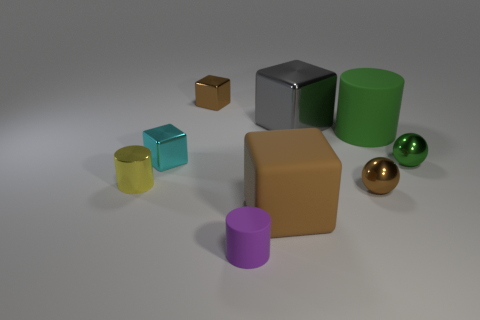What is the material of the tiny thing that is behind the small brown ball and on the right side of the rubber cube?
Your answer should be very brief. Metal. Is the number of small cylinders that are behind the big gray thing less than the number of green spheres that are behind the tiny brown shiny sphere?
Provide a short and direct response. Yes. There is a cyan thing that is the same material as the gray thing; what size is it?
Your answer should be compact. Small. Is there any other thing that is the same color as the large matte cylinder?
Keep it short and to the point. Yes. Is the purple object made of the same material as the cylinder on the right side of the purple rubber cylinder?
Give a very brief answer. Yes. What is the material of the tiny brown thing that is the same shape as the small cyan metallic thing?
Your response must be concise. Metal. Are there any other things that are made of the same material as the green cylinder?
Offer a terse response. Yes. Is the material of the small object on the left side of the tiny cyan metal block the same as the brown object that is on the left side of the tiny purple cylinder?
Your answer should be very brief. Yes. There is a cylinder that is behind the small cube that is to the left of the small cube that is behind the tiny cyan object; what color is it?
Ensure brevity in your answer.  Green. What number of other objects are there of the same shape as the purple thing?
Offer a very short reply. 2. 